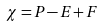Convert formula to latex. <formula><loc_0><loc_0><loc_500><loc_500>\chi = P - E + F</formula> 